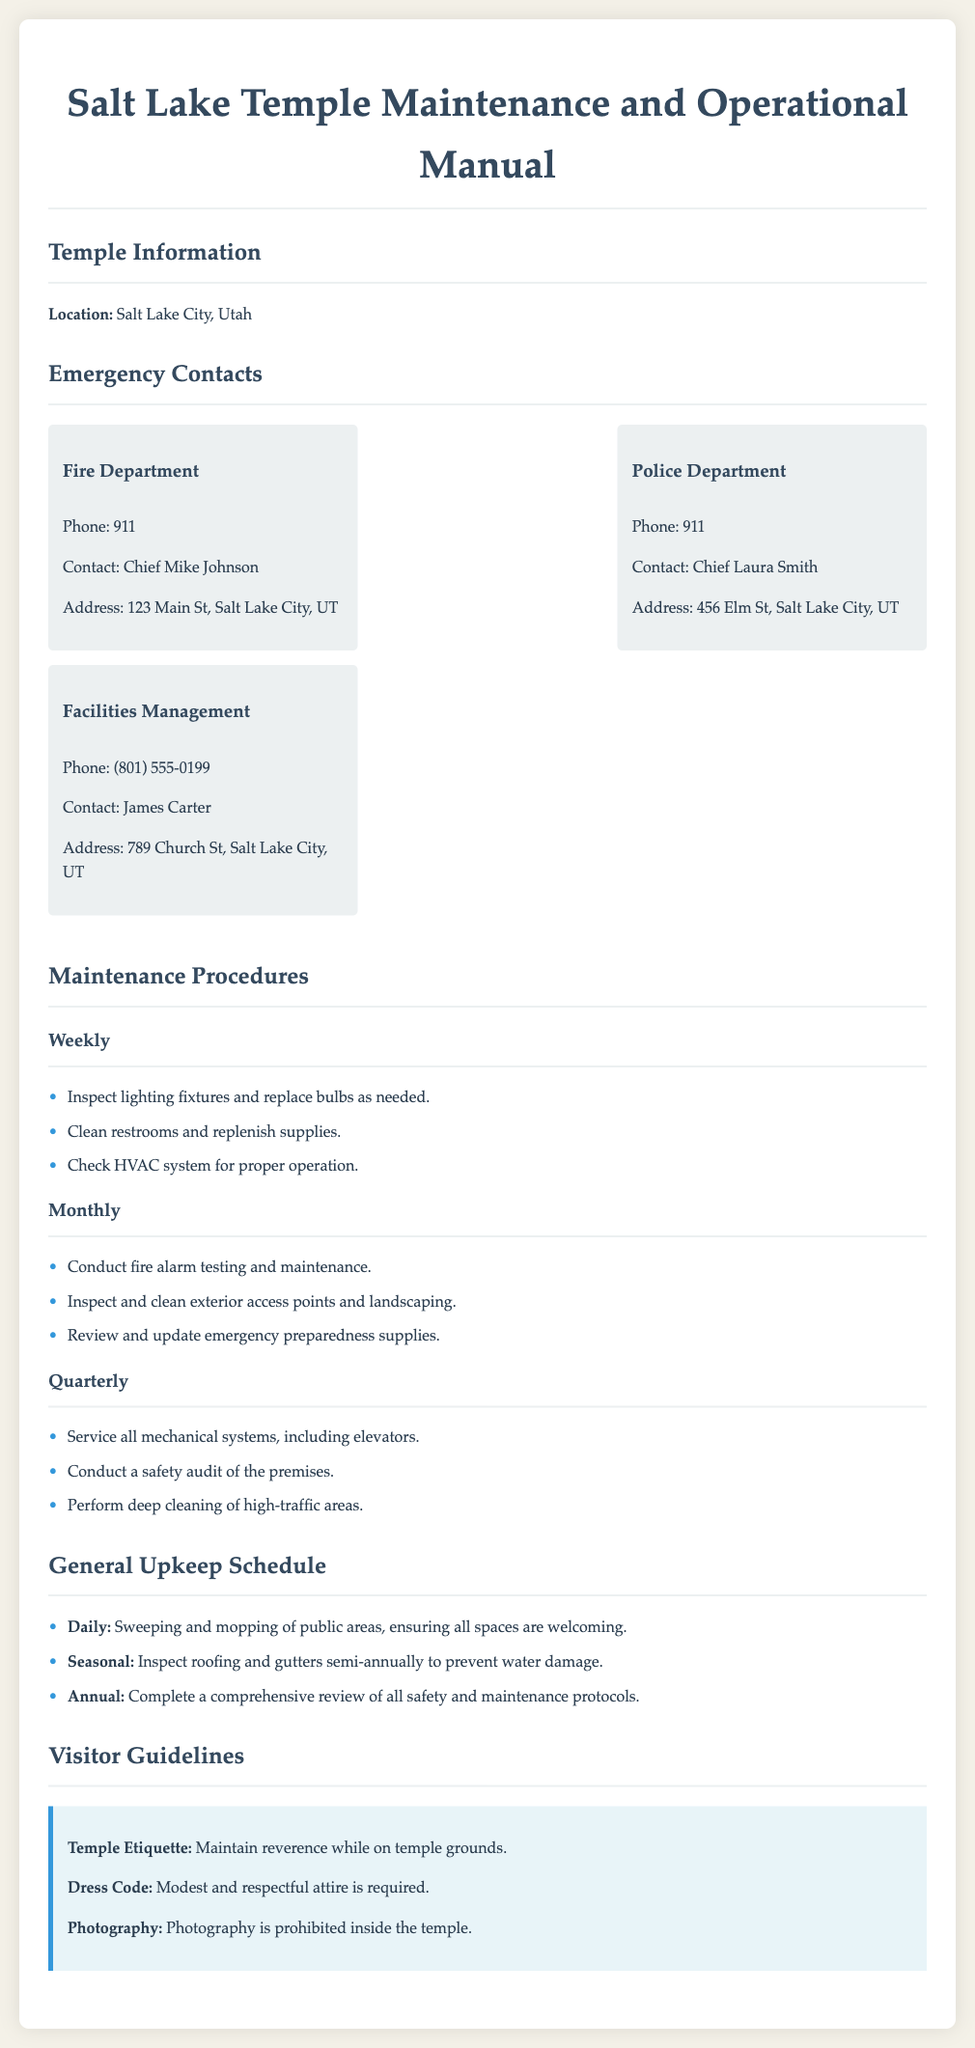What is the location of the temple? The document specifies that the location of the temple is Salt Lake City, Utah.
Answer: Salt Lake City, Utah Who is the contact for the Fire Department? The document lists Chief Mike Johnson as the contact person for the Fire Department.
Answer: Chief Mike Johnson What is the phone number for Facilities Management? The document states that the phone number for Facilities Management is (801) 555-0199.
Answer: (801) 555-0199 How often should fire alarm testing be conducted? The document indicates that fire alarm testing should be done monthly.
Answer: Monthly What should be inspected semi-annually? The document mentions that roofing and gutters should be inspected semi-annually to prevent water damage.
Answer: Roofing and gutters What is the dress code for visitors? The document specifies that modest and respectful attire is required.
Answer: Modest and respectful attire What is the required action for public areas daily? The document states that sweeping and mopping of public areas is a daily task.
Answer: Sweeping and mopping Who is the contact for the Police Department? The document lists Chief Laura Smith as the contact person for the Police Department.
Answer: Chief Laura Smith What kind of cleaning is performed quarterly? The document mentions that deep cleaning of high-traffic areas is performed quarterly.
Answer: Deep cleaning of high-traffic areas 